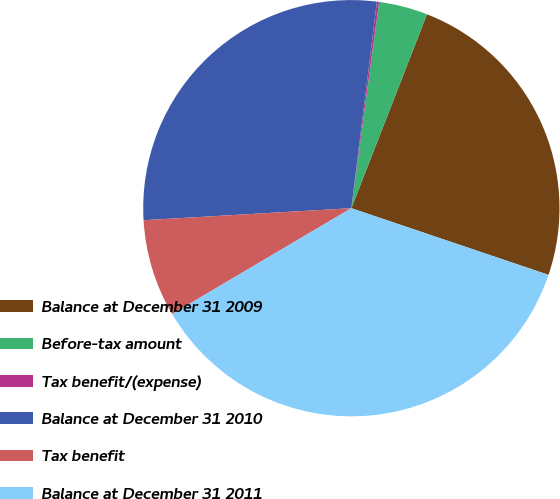Convert chart to OTSL. <chart><loc_0><loc_0><loc_500><loc_500><pie_chart><fcel>Balance at December 31 2009<fcel>Before-tax amount<fcel>Tax benefit/(expense)<fcel>Balance at December 31 2010<fcel>Tax benefit<fcel>Balance at December 31 2011<nl><fcel>24.27%<fcel>3.79%<fcel>0.17%<fcel>27.88%<fcel>7.57%<fcel>36.32%<nl></chart> 